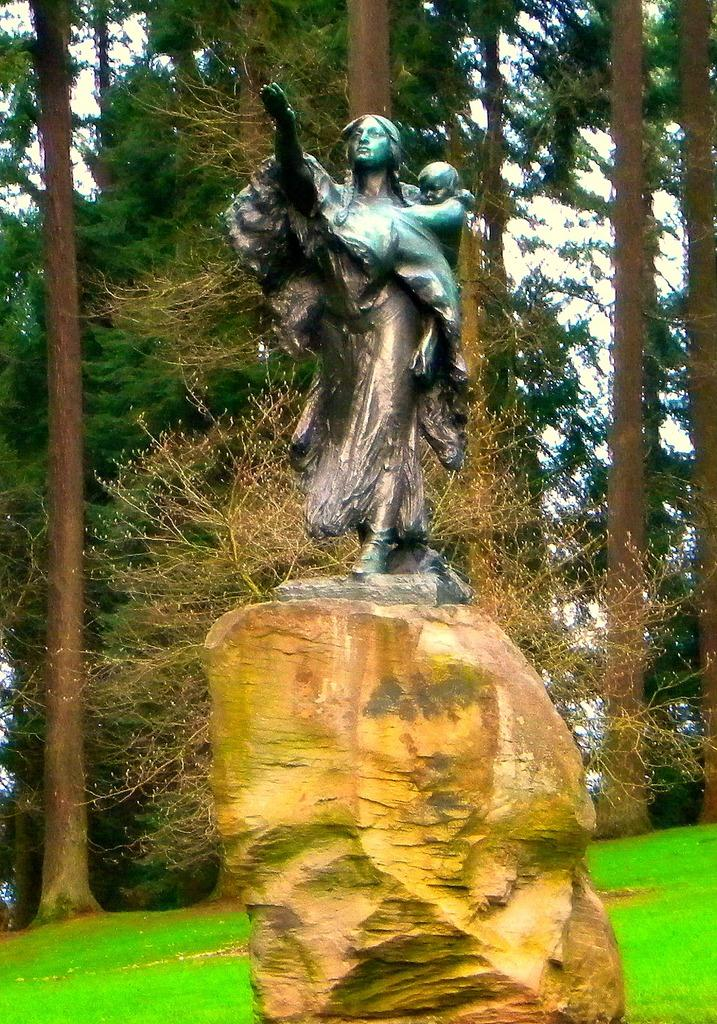What is the main subject of the image? There is a statue of a person in the image. Where is the statue located? The statue is on a rock. What is the person in the statue doing? The person in the statue is carrying a baby. What can be seen in the background of the image? There are trees behind the statue. What type of vegetation is present in the background? The trees are on grass land. What type of brush is the person in the statue using to paint the trees? There is no brush present in the image, and the person in the statue is not depicted as painting the trees. 